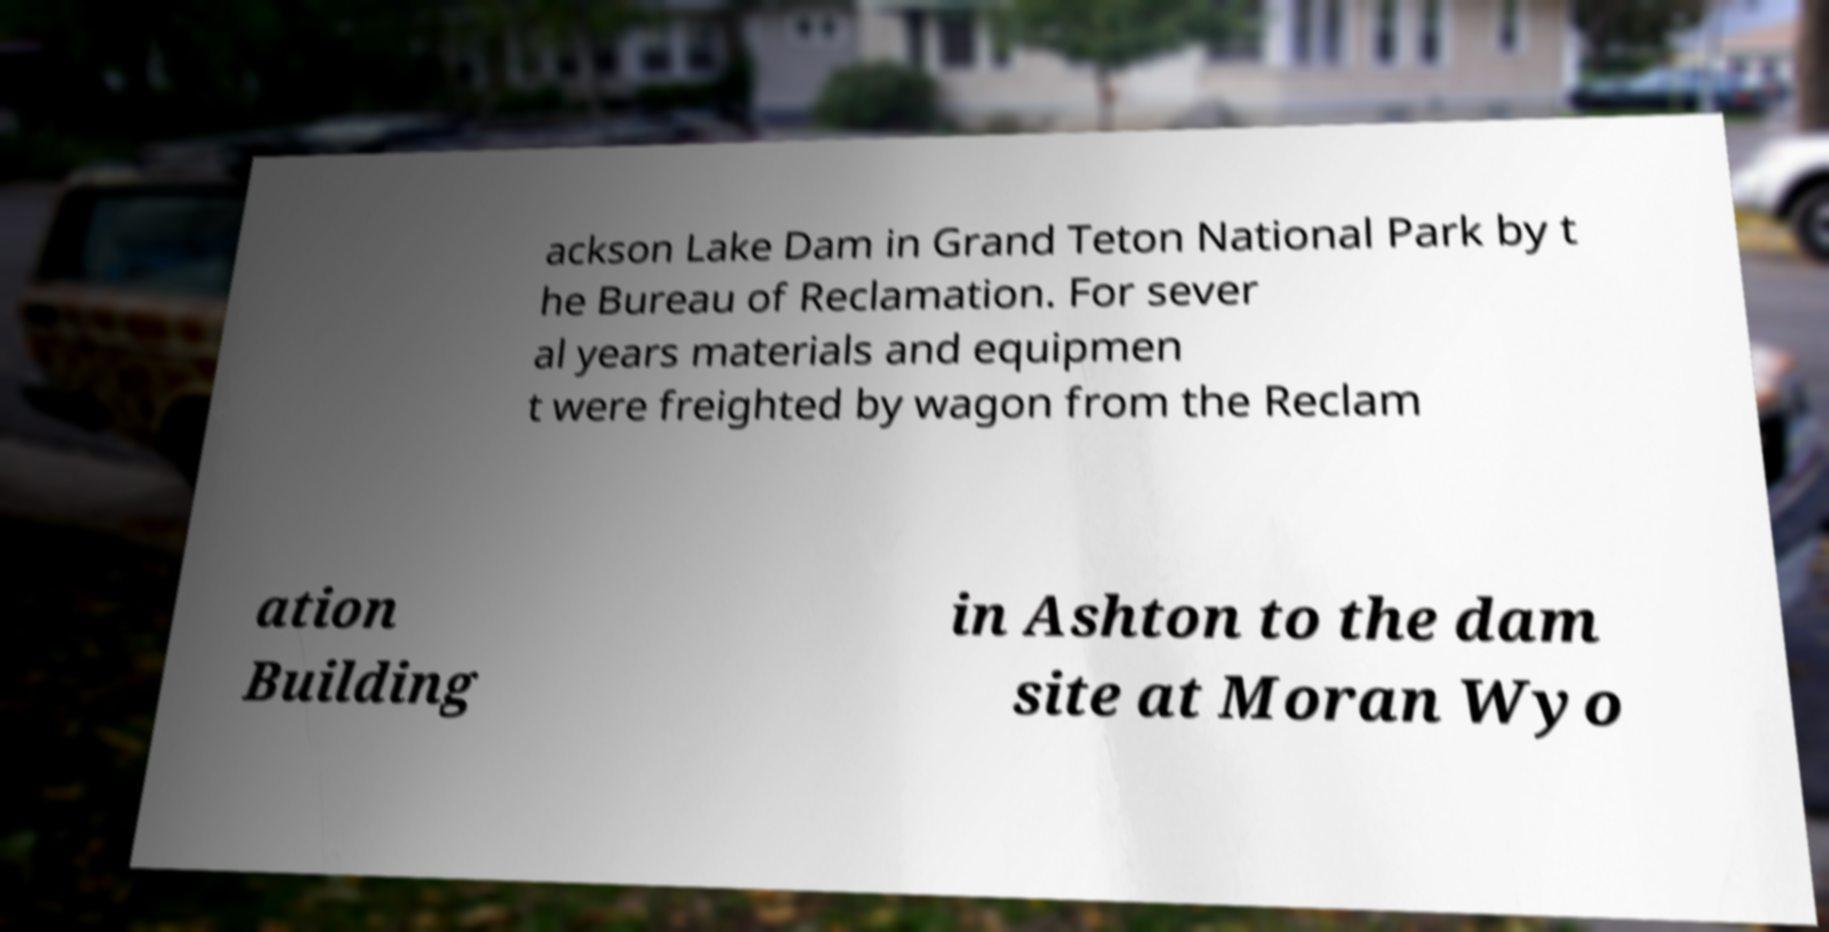What messages or text are displayed in this image? I need them in a readable, typed format. ackson Lake Dam in Grand Teton National Park by t he Bureau of Reclamation. For sever al years materials and equipmen t were freighted by wagon from the Reclam ation Building in Ashton to the dam site at Moran Wyo 